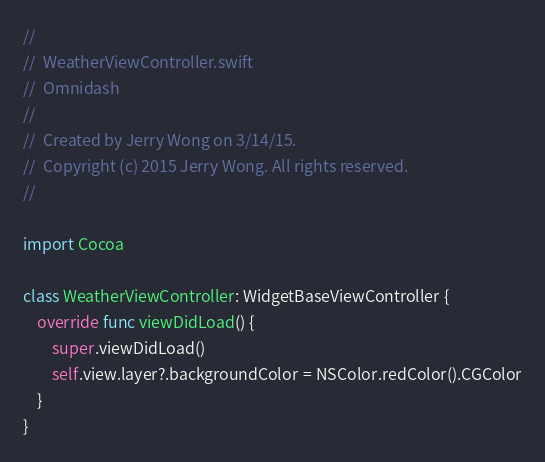Convert code to text. <code><loc_0><loc_0><loc_500><loc_500><_Swift_>//
//  WeatherViewController.swift
//  Omnidash
//
//  Created by Jerry Wong on 3/14/15.
//  Copyright (c) 2015 Jerry Wong. All rights reserved.
//

import Cocoa

class WeatherViewController: WidgetBaseViewController {
    override func viewDidLoad() {
        super.viewDidLoad()
        self.view.layer?.backgroundColor = NSColor.redColor().CGColor
    }
}
</code> 